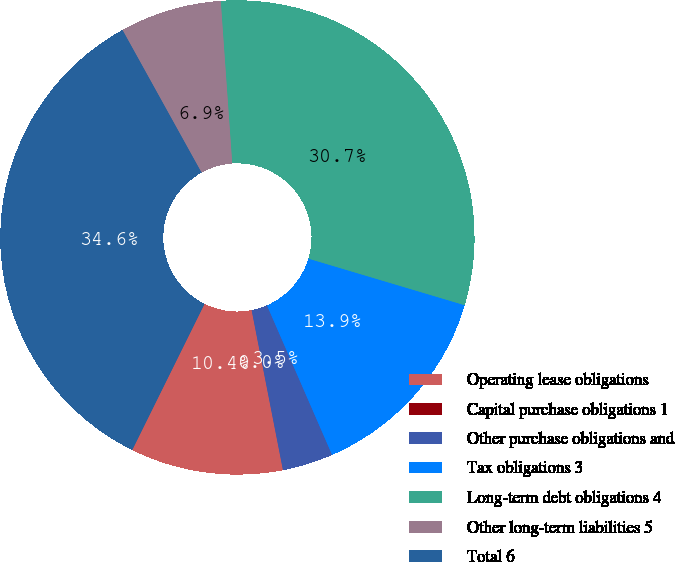Convert chart to OTSL. <chart><loc_0><loc_0><loc_500><loc_500><pie_chart><fcel>Operating lease obligations<fcel>Capital purchase obligations 1<fcel>Other purchase obligations and<fcel>Tax obligations 3<fcel>Long-term debt obligations 4<fcel>Other long-term liabilities 5<fcel>Total 6<nl><fcel>10.39%<fcel>0.0%<fcel>3.46%<fcel>13.85%<fcel>30.73%<fcel>6.93%<fcel>34.63%<nl></chart> 